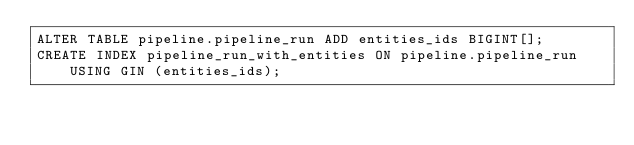Convert code to text. <code><loc_0><loc_0><loc_500><loc_500><_SQL_>ALTER TABLE pipeline.pipeline_run ADD entities_ids BIGINT[];
CREATE INDEX pipeline_run_with_entities ON pipeline.pipeline_run USING GIN (entities_ids);</code> 